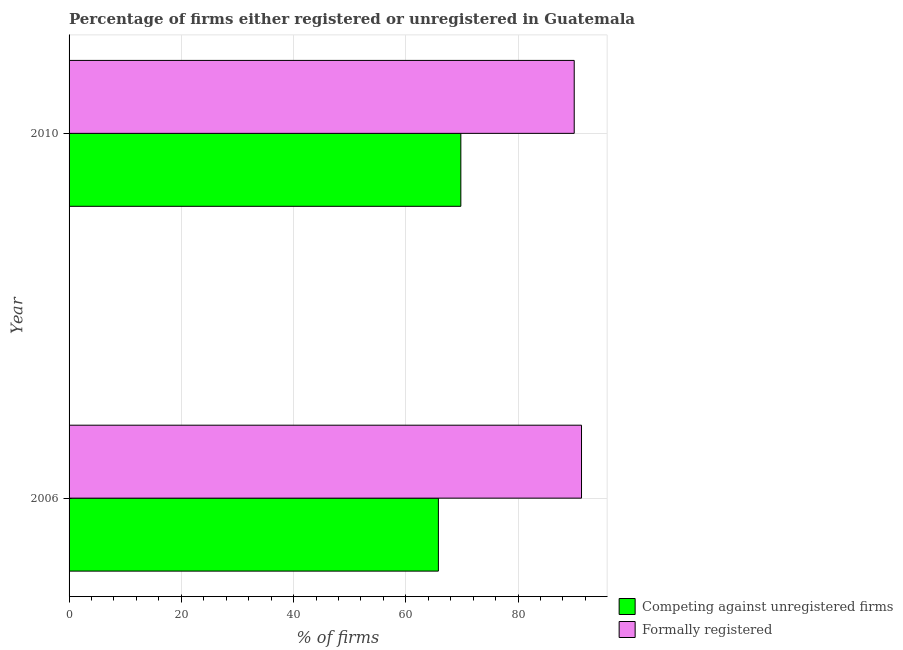How many groups of bars are there?
Keep it short and to the point. 2. Are the number of bars per tick equal to the number of legend labels?
Ensure brevity in your answer.  Yes. Are the number of bars on each tick of the Y-axis equal?
Ensure brevity in your answer.  Yes. What is the label of the 1st group of bars from the top?
Offer a terse response. 2010. What is the percentage of registered firms in 2006?
Your response must be concise. 65.8. Across all years, what is the maximum percentage of registered firms?
Offer a very short reply. 69.8. Across all years, what is the minimum percentage of formally registered firms?
Provide a succinct answer. 90. What is the total percentage of registered firms in the graph?
Ensure brevity in your answer.  135.6. What is the difference between the percentage of formally registered firms in 2010 and the percentage of registered firms in 2006?
Offer a terse response. 24.2. What is the average percentage of registered firms per year?
Offer a very short reply. 67.8. In the year 2006, what is the difference between the percentage of registered firms and percentage of formally registered firms?
Keep it short and to the point. -25.5. What is the ratio of the percentage of registered firms in 2006 to that in 2010?
Ensure brevity in your answer.  0.94. Is the percentage of formally registered firms in 2006 less than that in 2010?
Make the answer very short. No. What does the 2nd bar from the top in 2010 represents?
Your answer should be very brief. Competing against unregistered firms. What does the 2nd bar from the bottom in 2006 represents?
Offer a very short reply. Formally registered. Where does the legend appear in the graph?
Make the answer very short. Bottom right. How many legend labels are there?
Give a very brief answer. 2. What is the title of the graph?
Provide a short and direct response. Percentage of firms either registered or unregistered in Guatemala. Does "Commercial service imports" appear as one of the legend labels in the graph?
Keep it short and to the point. No. What is the label or title of the X-axis?
Ensure brevity in your answer.  % of firms. What is the % of firms in Competing against unregistered firms in 2006?
Provide a short and direct response. 65.8. What is the % of firms of Formally registered in 2006?
Offer a very short reply. 91.3. What is the % of firms in Competing against unregistered firms in 2010?
Provide a short and direct response. 69.8. Across all years, what is the maximum % of firms of Competing against unregistered firms?
Provide a short and direct response. 69.8. Across all years, what is the maximum % of firms in Formally registered?
Your response must be concise. 91.3. Across all years, what is the minimum % of firms of Competing against unregistered firms?
Offer a very short reply. 65.8. What is the total % of firms of Competing against unregistered firms in the graph?
Ensure brevity in your answer.  135.6. What is the total % of firms of Formally registered in the graph?
Make the answer very short. 181.3. What is the difference between the % of firms of Competing against unregistered firms in 2006 and that in 2010?
Your response must be concise. -4. What is the difference between the % of firms of Competing against unregistered firms in 2006 and the % of firms of Formally registered in 2010?
Make the answer very short. -24.2. What is the average % of firms in Competing against unregistered firms per year?
Ensure brevity in your answer.  67.8. What is the average % of firms in Formally registered per year?
Provide a short and direct response. 90.65. In the year 2006, what is the difference between the % of firms of Competing against unregistered firms and % of firms of Formally registered?
Keep it short and to the point. -25.5. In the year 2010, what is the difference between the % of firms of Competing against unregistered firms and % of firms of Formally registered?
Give a very brief answer. -20.2. What is the ratio of the % of firms of Competing against unregistered firms in 2006 to that in 2010?
Ensure brevity in your answer.  0.94. What is the ratio of the % of firms of Formally registered in 2006 to that in 2010?
Ensure brevity in your answer.  1.01. What is the difference between the highest and the second highest % of firms in Formally registered?
Offer a very short reply. 1.3. What is the difference between the highest and the lowest % of firms of Formally registered?
Make the answer very short. 1.3. 